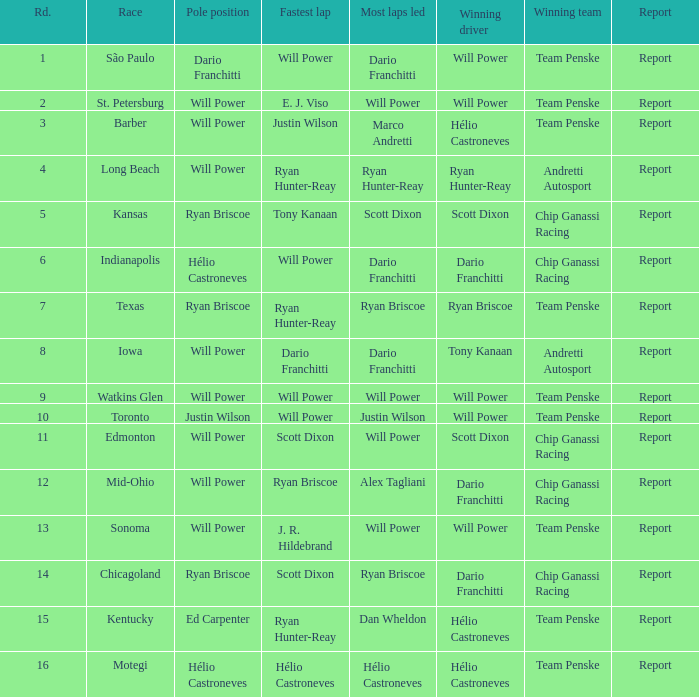At chicagoland, what was the finishing position of the driver who won? 1.0. 